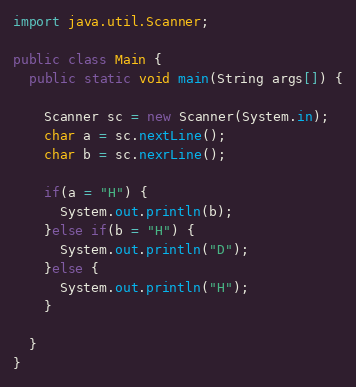Convert code to text. <code><loc_0><loc_0><loc_500><loc_500><_Java_>import java.util.Scanner;
 
public class Main {
  public static void main(String args[]) {
    
    Scanner sc = new Scanner(System.in);
    char a = sc.nextLine();
    char b = sc.nexrLine();
 
    if(a = "H") {
      System.out.println(b);
    }else if(b = "H") {
      System.out.println("D");
    }else {
      System.out.println("H");
    }
 
  }
}</code> 